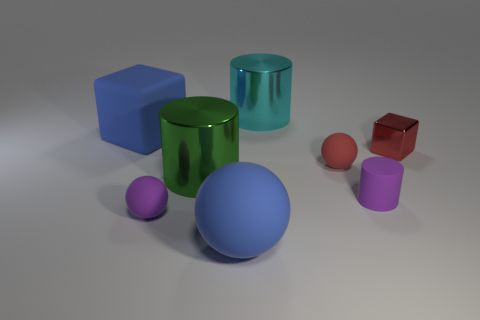Subtract 1 spheres. How many spheres are left? 2 Add 1 small red balls. How many objects exist? 9 Subtract all spheres. How many objects are left? 5 Add 1 big blue things. How many big blue things are left? 3 Add 8 small purple cylinders. How many small purple cylinders exist? 9 Subtract 0 gray cubes. How many objects are left? 8 Subtract all small gray matte objects. Subtract all small red matte things. How many objects are left? 7 